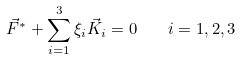<formula> <loc_0><loc_0><loc_500><loc_500>\vec { F } ^ { * } + \sum _ { i = 1 } ^ { 3 } \xi _ { i } \vec { K } _ { i } = 0 \quad i = 1 , 2 , 3</formula> 